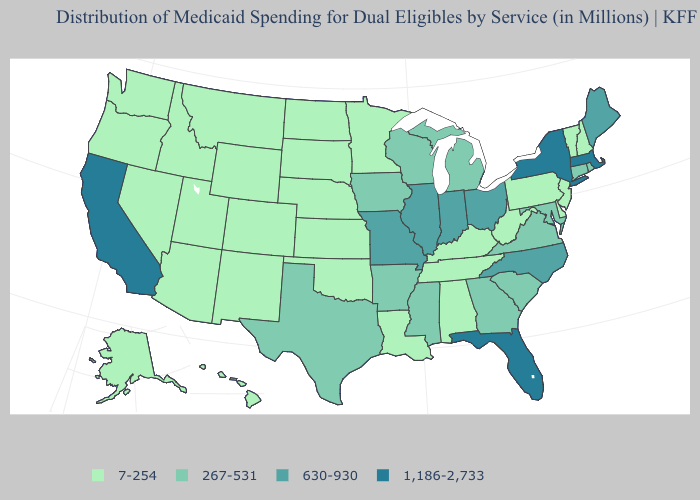Is the legend a continuous bar?
Keep it brief. No. Does the map have missing data?
Give a very brief answer. No. Name the states that have a value in the range 7-254?
Quick response, please. Alabama, Alaska, Arizona, Colorado, Delaware, Hawaii, Idaho, Kansas, Kentucky, Louisiana, Minnesota, Montana, Nebraska, Nevada, New Hampshire, New Jersey, New Mexico, North Dakota, Oklahoma, Oregon, Pennsylvania, South Dakota, Tennessee, Utah, Vermont, Washington, West Virginia, Wyoming. Does the map have missing data?
Answer briefly. No. What is the value of Hawaii?
Be succinct. 7-254. Among the states that border Oregon , does Nevada have the highest value?
Short answer required. No. What is the lowest value in states that border Rhode Island?
Short answer required. 267-531. Which states have the lowest value in the MidWest?
Answer briefly. Kansas, Minnesota, Nebraska, North Dakota, South Dakota. Name the states that have a value in the range 1,186-2,733?
Give a very brief answer. California, Florida, Massachusetts, New York. What is the highest value in the MidWest ?
Quick response, please. 630-930. What is the value of Indiana?
Give a very brief answer. 630-930. Does Ohio have a lower value than California?
Be succinct. Yes. What is the value of Oklahoma?
Keep it brief. 7-254. What is the highest value in the South ?
Be succinct. 1,186-2,733. What is the value of Virginia?
Concise answer only. 267-531. 